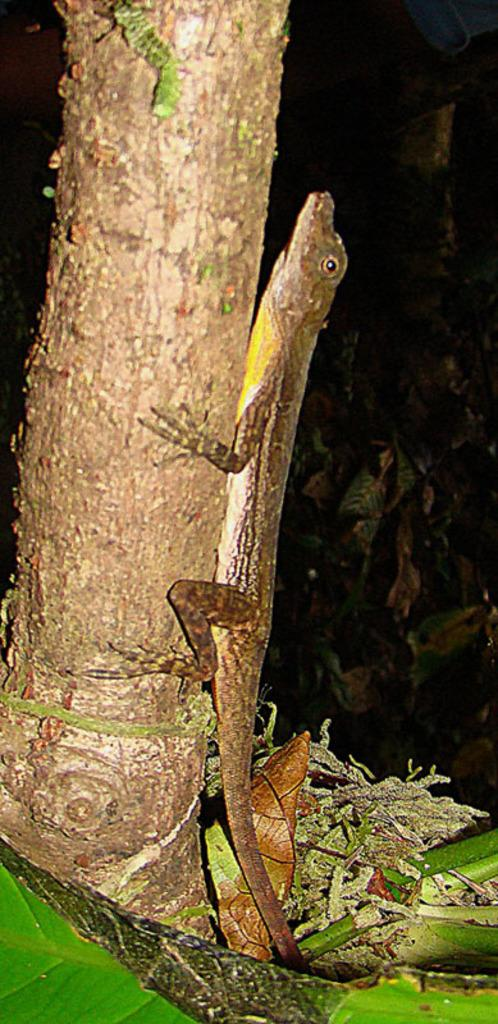What type of animal is in the image? There is a lizard-like animal in the image. Where is the animal located? The animal is on the trunk of a tree. What can be seen at the bottom of the image? There are dry leaves at the bottom of the image. How would you describe the overall lighting in the image? The background of the image is dark. How many boats are visible in the image? There are no boats present in the image. Can you describe the gate in the image? There is no gate present in the image. 